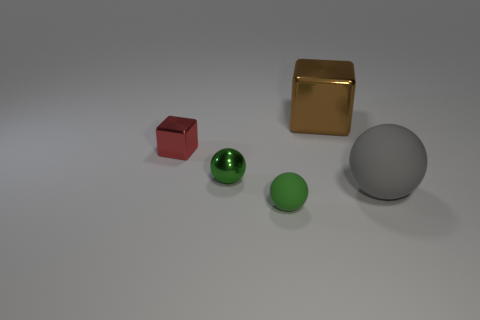What is the material of the big gray sphere?
Provide a succinct answer. Rubber. The small green sphere in front of the matte sphere behind the tiny thing that is right of the tiny green metal object is made of what material?
Provide a short and direct response. Rubber. Do the red thing and the gray rubber thing have the same size?
Offer a terse response. No. There is a thing that is both behind the small metallic ball and right of the tiny rubber ball; what shape is it?
Provide a short and direct response. Cube. How many small red cubes have the same material as the big brown cube?
Provide a short and direct response. 1. What number of tiny objects are behind the tiny metallic thing to the right of the small red cube?
Your answer should be very brief. 1. What is the shape of the tiny object in front of the large object right of the big thing that is behind the small shiny block?
Make the answer very short. Sphere. How many things are large blue cubes or rubber things?
Offer a very short reply. 2. What is the color of the cube that is the same size as the green rubber thing?
Keep it short and to the point. Red. There is a green rubber object; is it the same shape as the small shiny object behind the green metal object?
Your answer should be very brief. No. 